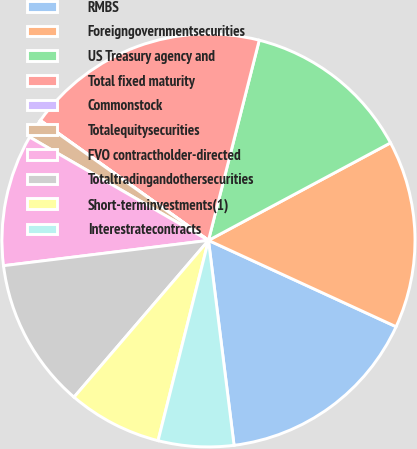<chart> <loc_0><loc_0><loc_500><loc_500><pie_chart><fcel>RMBS<fcel>Foreigngovernmentsecurities<fcel>US Treasury agency and<fcel>Total fixed maturity<fcel>Commonstock<fcel>Totalequitysecurities<fcel>FVO contractholder-directed<fcel>Totaltradingandothersecurities<fcel>Short-terminvestments(1)<fcel>Interestratecontracts<nl><fcel>16.16%<fcel>14.69%<fcel>13.22%<fcel>19.09%<fcel>0.03%<fcel>1.5%<fcel>10.29%<fcel>11.76%<fcel>7.36%<fcel>5.9%<nl></chart> 